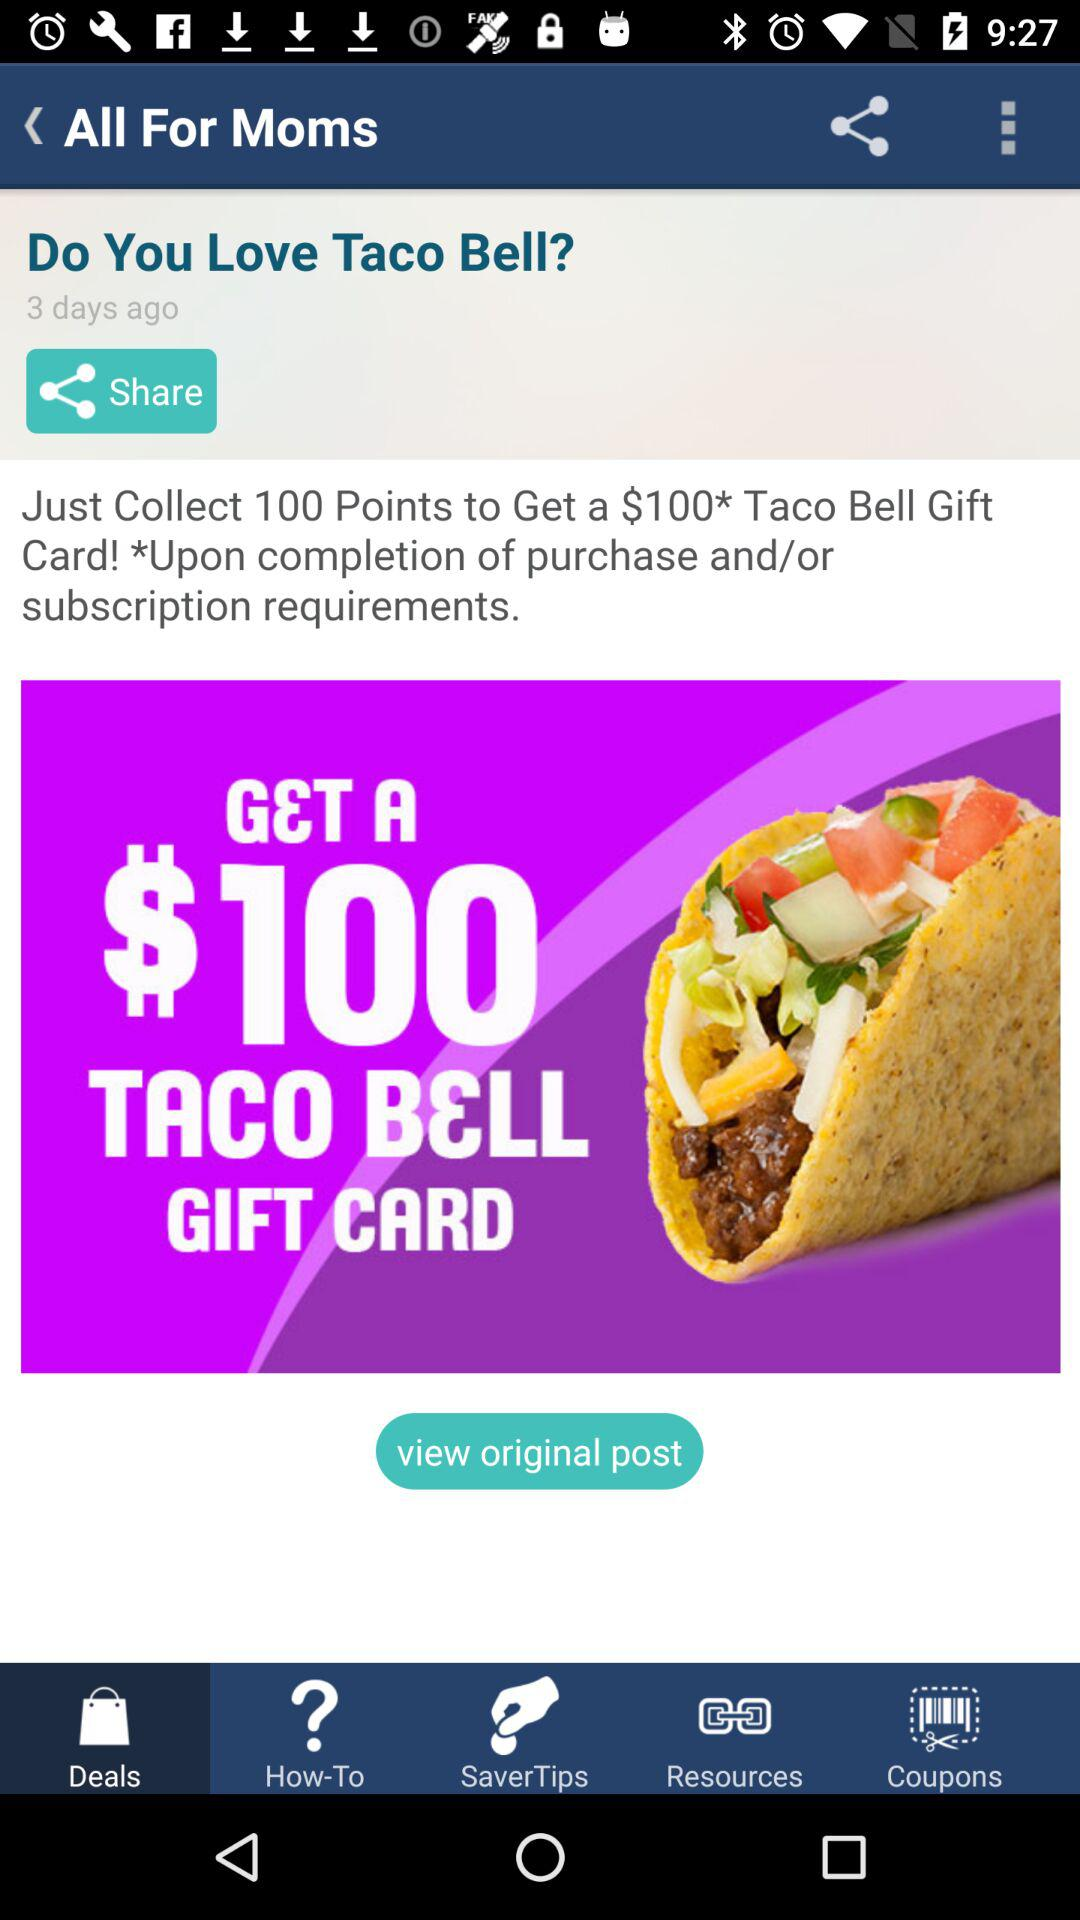Which tab is selected? The selected tab is "Deals". 